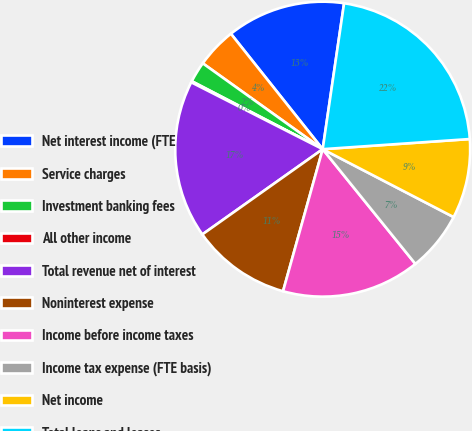Convert chart to OTSL. <chart><loc_0><loc_0><loc_500><loc_500><pie_chart><fcel>Net interest income (FTE<fcel>Service charges<fcel>Investment banking fees<fcel>All other income<fcel>Total revenue net of interest<fcel>Noninterest expense<fcel>Income before income taxes<fcel>Income tax expense (FTE basis)<fcel>Net income<fcel>Total loans and leases<nl><fcel>13.01%<fcel>4.42%<fcel>2.27%<fcel>0.13%<fcel>17.3%<fcel>10.86%<fcel>15.15%<fcel>6.57%<fcel>8.71%<fcel>21.59%<nl></chart> 